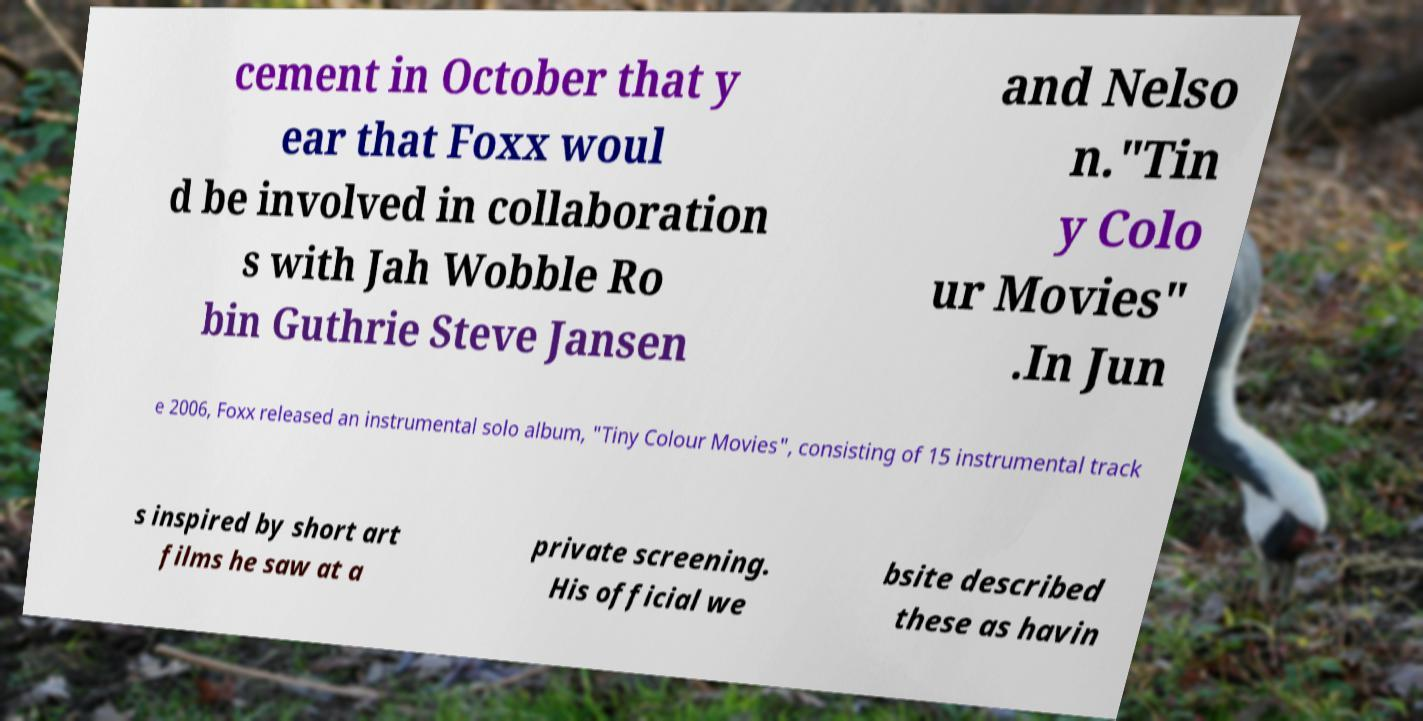Please read and relay the text visible in this image. What does it say? cement in October that y ear that Foxx woul d be involved in collaboration s with Jah Wobble Ro bin Guthrie Steve Jansen and Nelso n."Tin y Colo ur Movies" .In Jun e 2006, Foxx released an instrumental solo album, "Tiny Colour Movies", consisting of 15 instrumental track s inspired by short art films he saw at a private screening. His official we bsite described these as havin 